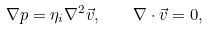Convert formula to latex. <formula><loc_0><loc_0><loc_500><loc_500>\nabla p = \eta _ { i } \nabla ^ { 2 } \vec { v } , \quad \nabla \cdot \vec { v } = 0 ,</formula> 